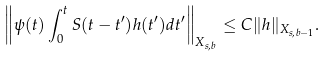Convert formula to latex. <formula><loc_0><loc_0><loc_500><loc_500>\left \| \psi ( t ) \int _ { 0 } ^ { t } S ( t - t ^ { \prime } ) h ( t ^ { \prime } ) d t ^ { \prime } \right \| _ { X _ { s , b } } \leq C \| h \| _ { X _ { s , b - 1 } } .</formula> 